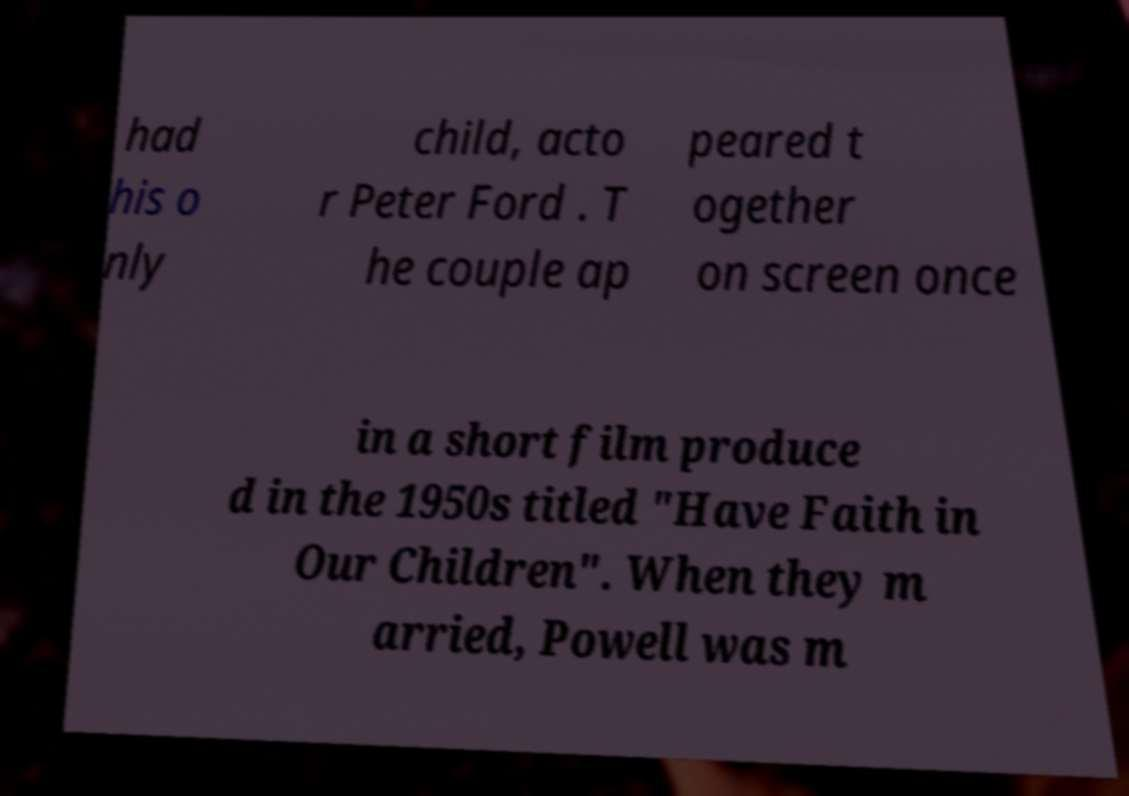Could you extract and type out the text from this image? had his o nly child, acto r Peter Ford . T he couple ap peared t ogether on screen once in a short film produce d in the 1950s titled "Have Faith in Our Children". When they m arried, Powell was m 